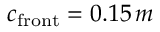Convert formula to latex. <formula><loc_0><loc_0><loc_500><loc_500>c _ { f r o n t } = 0 . 1 5 \, m</formula> 